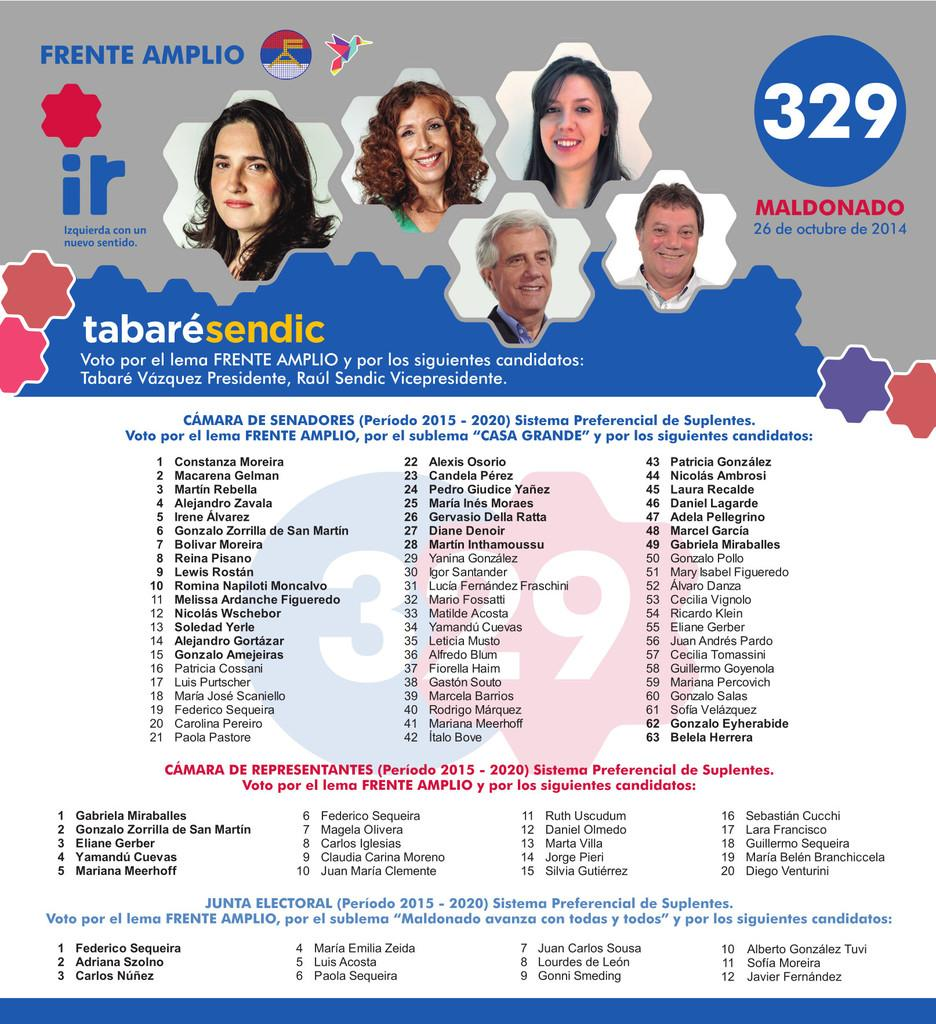What is depicted on the poster in the image? There is a poster in the image with faces of women and men on it. What else can be seen in the image besides the poster? There is a bird flying in the image, a flag, text, and numbers. What type of ear can be seen on the bird in the image? There is no ear visible on the bird in the image, as birds do not have external ears like mammals. 